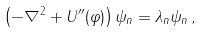Convert formula to latex. <formula><loc_0><loc_0><loc_500><loc_500>\left ( - \nabla ^ { 2 } + U ^ { \prime \prime } ( \varphi ) \right ) \psi _ { n } = \lambda _ { n } \psi _ { n } \, ,</formula> 